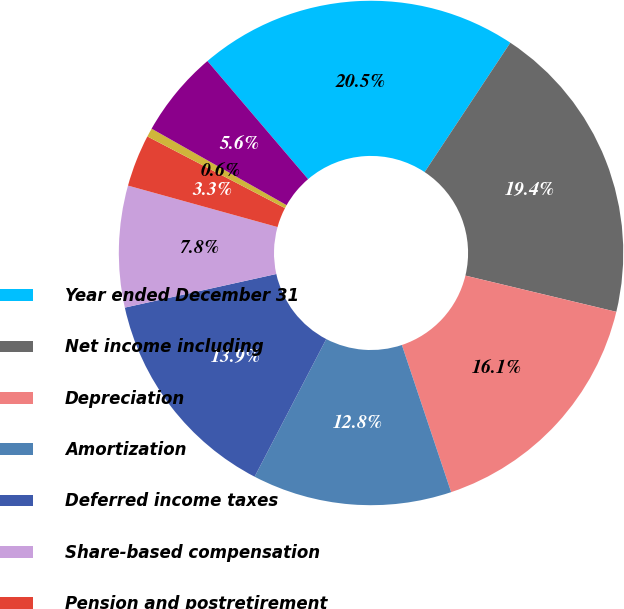Convert chart. <chart><loc_0><loc_0><loc_500><loc_500><pie_chart><fcel>Year ended December 31<fcel>Net income including<fcel>Depreciation<fcel>Amortization<fcel>Deferred income taxes<fcel>Share-based compensation<fcel>Pension and postretirement<fcel>Restructuring charges net of<fcel>(Gain) Loss on sale of<nl><fcel>20.55%<fcel>19.44%<fcel>16.11%<fcel>12.78%<fcel>13.89%<fcel>7.78%<fcel>3.34%<fcel>0.56%<fcel>5.56%<nl></chart> 